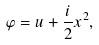<formula> <loc_0><loc_0><loc_500><loc_500>\varphi = u + \frac { i } { 2 } x ^ { 2 } ,</formula> 